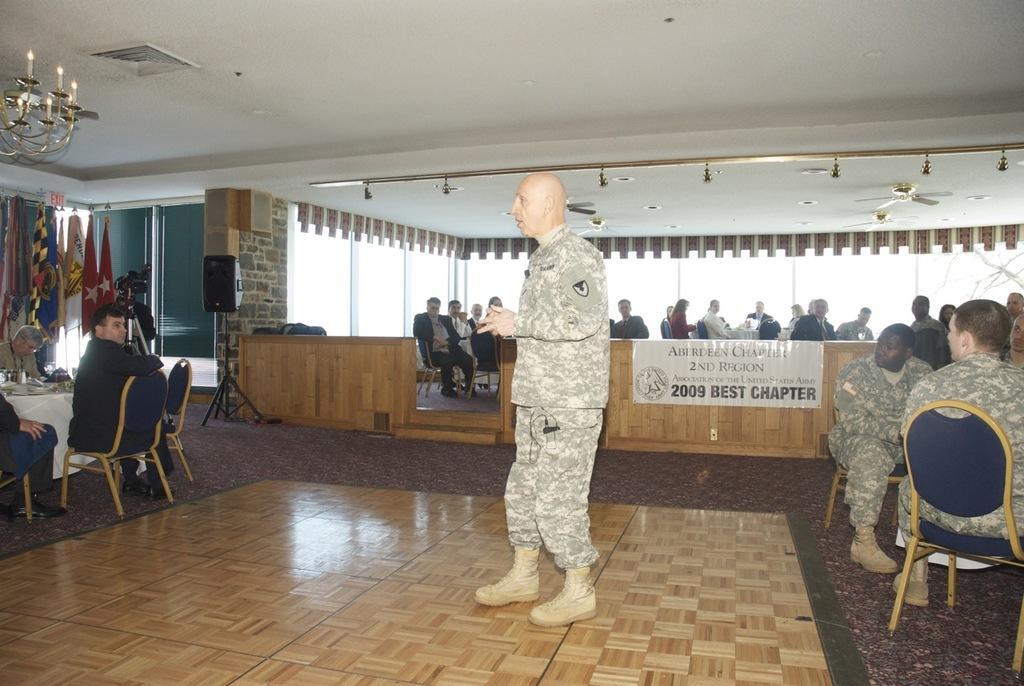In one or two sentences, can you explain what this image depicts? In this picture we can see man standing in center and on left side some people are sitting on chairs and watching at him and at right side also the same people are watching and whole crowd is watching to them to him and here it is a speaker, flag with poles and this is a floor and here we can see chandelier. 